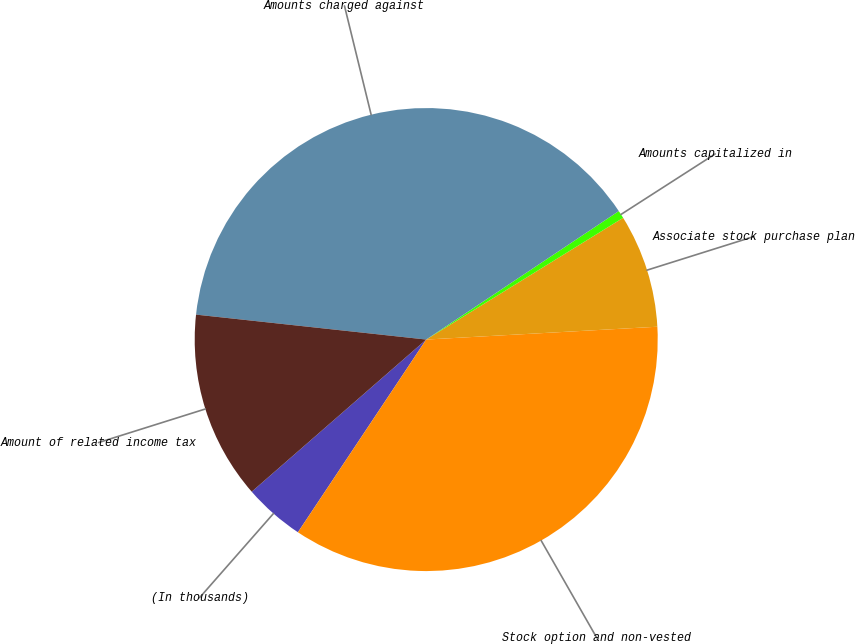Convert chart. <chart><loc_0><loc_0><loc_500><loc_500><pie_chart><fcel>(In thousands)<fcel>Stock option and non-vested<fcel>Associate stock purchase plan<fcel>Amounts capitalized in<fcel>Amounts charged against<fcel>Amount of related income tax<nl><fcel>4.24%<fcel>35.23%<fcel>7.93%<fcel>0.55%<fcel>38.92%<fcel>13.13%<nl></chart> 